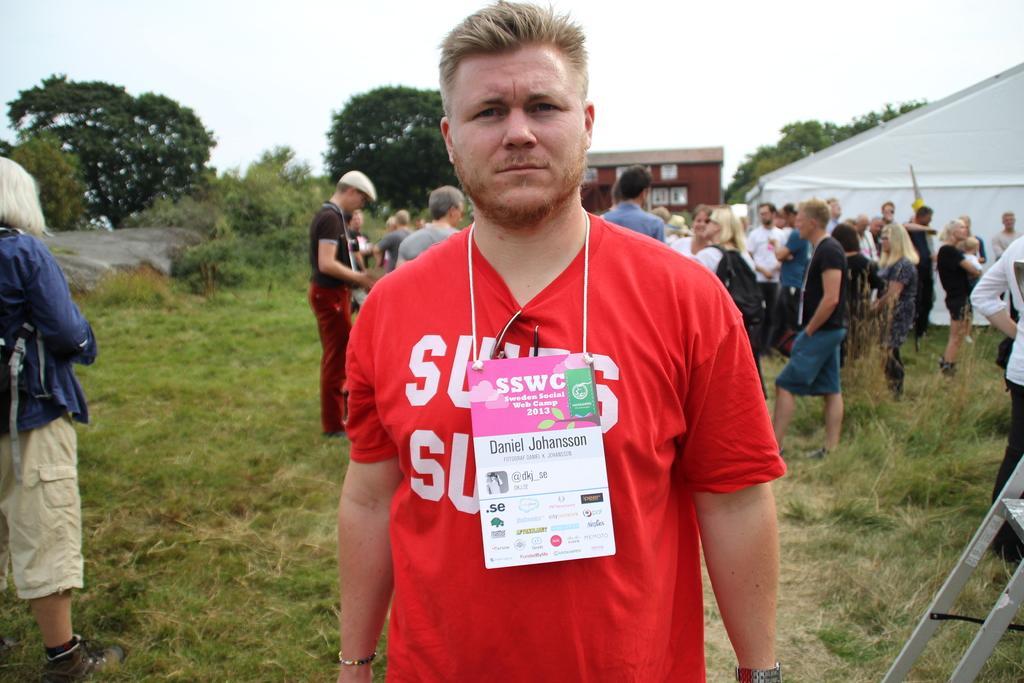Can you describe this image briefly? In this image I can see the grass. I can see some people. On the right side, I can see a tent. In the background, I can see a building and the trees. I can see the sky. 